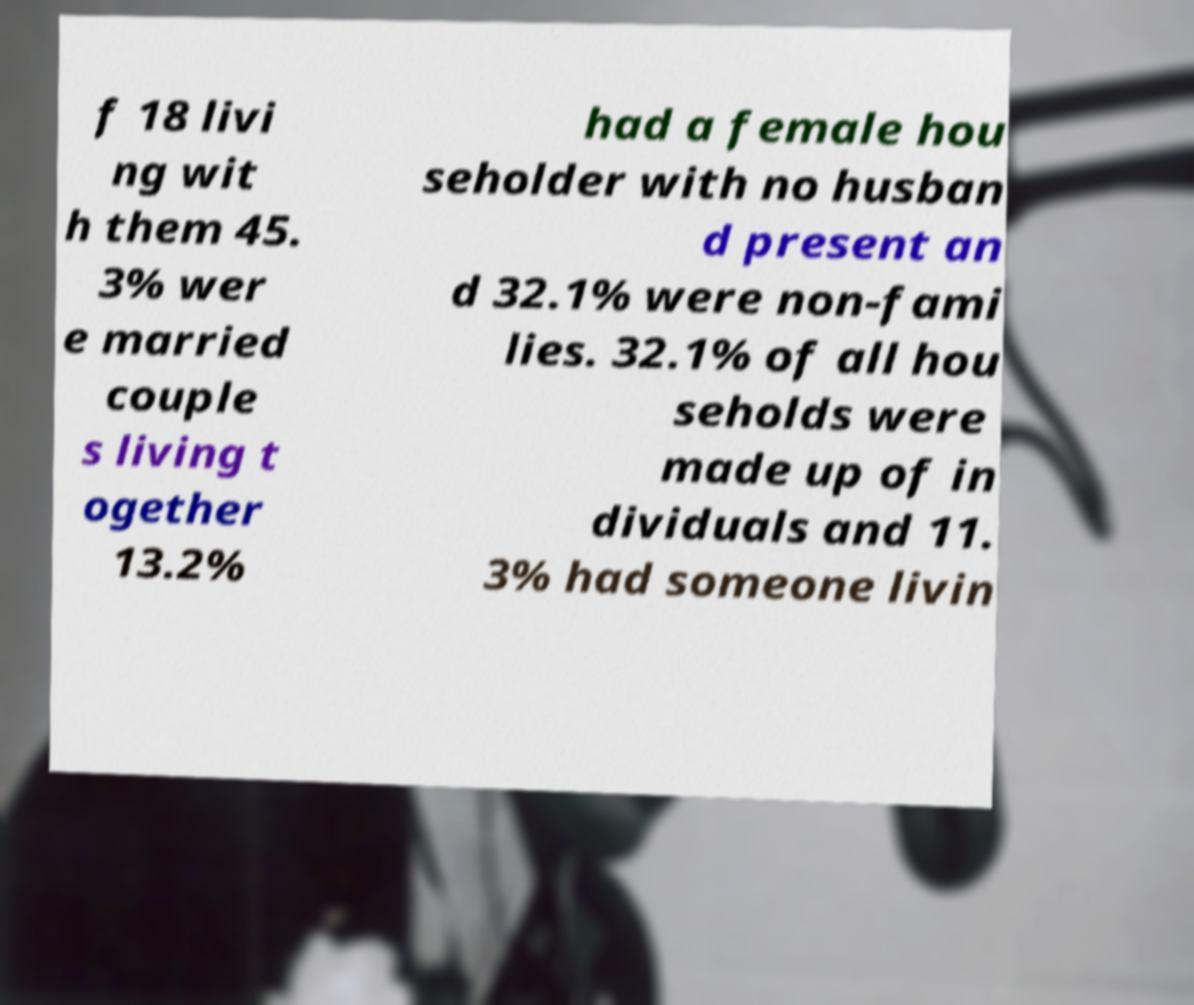Please read and relay the text visible in this image. What does it say? f 18 livi ng wit h them 45. 3% wer e married couple s living t ogether 13.2% had a female hou seholder with no husban d present an d 32.1% were non-fami lies. 32.1% of all hou seholds were made up of in dividuals and 11. 3% had someone livin 